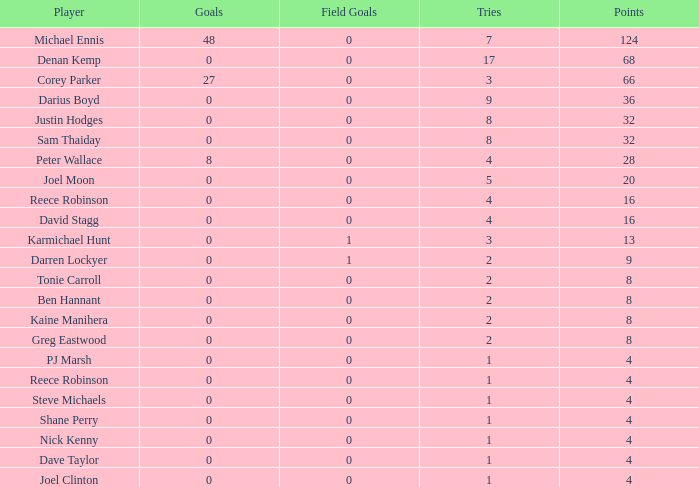How many goals did the player with less than 4 points have? 0.0. 